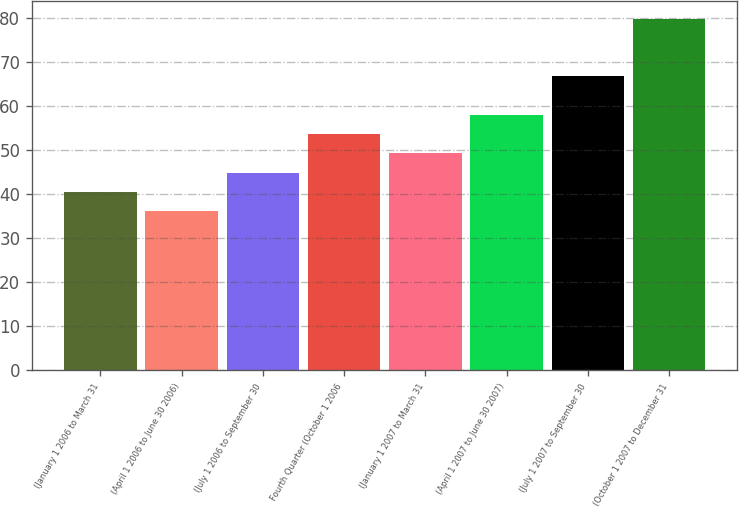Convert chart to OTSL. <chart><loc_0><loc_0><loc_500><loc_500><bar_chart><fcel>(January 1 2006 to March 31<fcel>(April 1 2006 to June 30 2006)<fcel>(July 1 2006 to September 30<fcel>Fourth Quarter (October 1 2006<fcel>(January 1 2007 to March 31<fcel>(April 1 2007 to June 30 2007)<fcel>(July 1 2007 to September 30<fcel>(October 1 2007 to December 31<nl><fcel>40.49<fcel>36.12<fcel>44.86<fcel>53.6<fcel>49.23<fcel>57.97<fcel>66.7<fcel>79.8<nl></chart> 